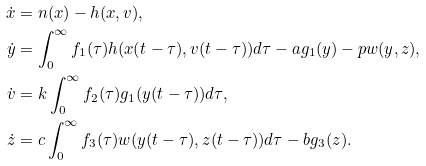<formula> <loc_0><loc_0><loc_500><loc_500>\dot { x } & = n ( x ) - h ( x , v ) , \\ \dot { y } & = \int _ { 0 } ^ { \infty } f _ { 1 } ( \tau ) h ( x ( t - \tau ) , v ( t - \tau ) ) d \tau - a g _ { 1 } ( y ) - p w ( y , z ) , \\ \dot { v } & = k \int _ { 0 } ^ { \infty } f _ { 2 } ( \tau ) g _ { 1 } ( y ( t - \tau ) ) d \tau , \\ \dot { z } & = c \int _ { 0 } ^ { \infty } f _ { 3 } ( \tau ) w ( y ( t - \tau ) , z ( t - \tau ) ) d \tau - b g _ { 3 } ( z ) .</formula> 